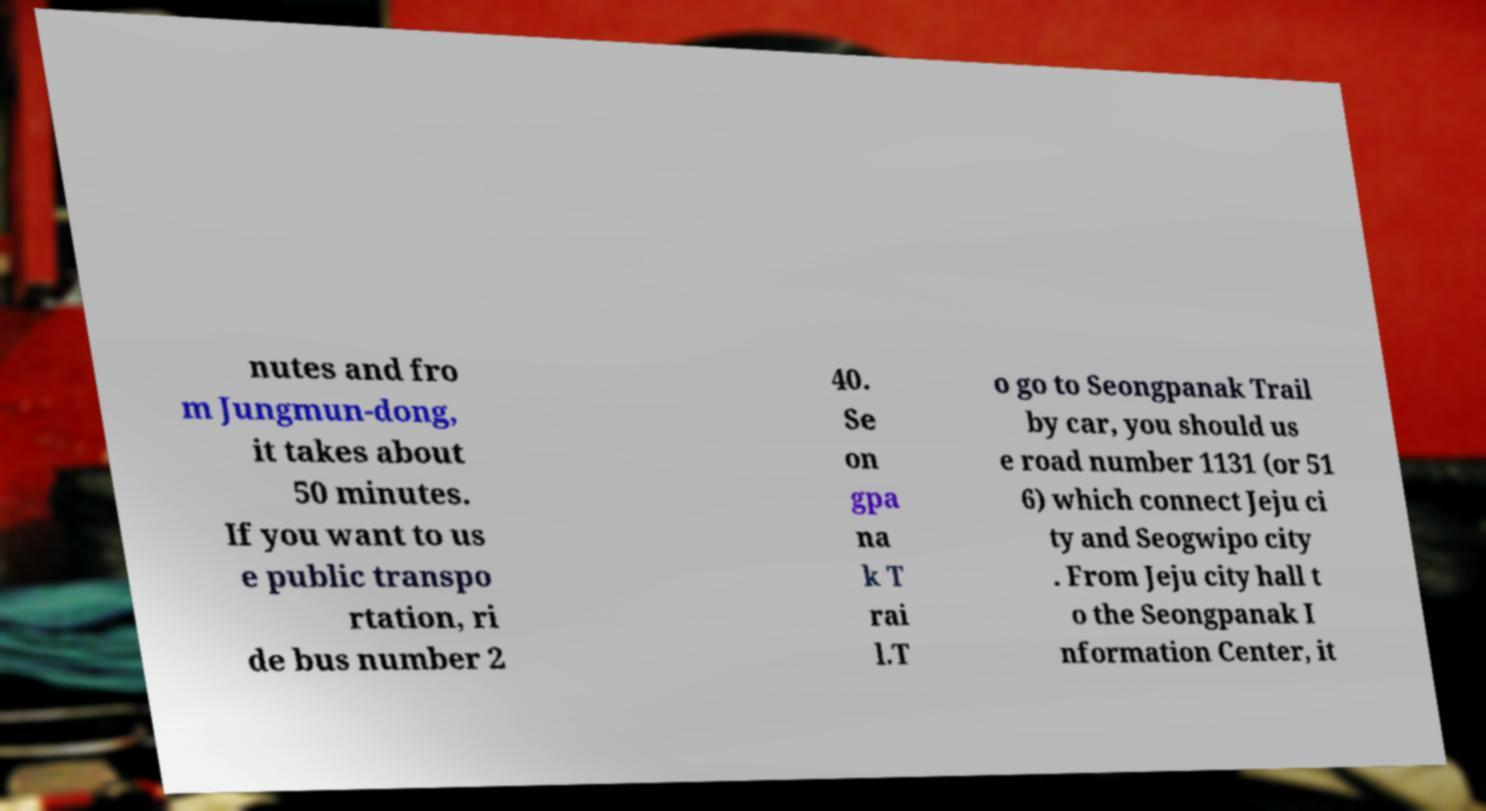Can you accurately transcribe the text from the provided image for me? nutes and fro m Jungmun-dong, it takes about 50 minutes. If you want to us e public transpo rtation, ri de bus number 2 40. Se on gpa na k T rai l.T o go to Seongpanak Trail by car, you should us e road number 1131 (or 51 6) which connect Jeju ci ty and Seogwipo city . From Jeju city hall t o the Seongpanak I nformation Center, it 